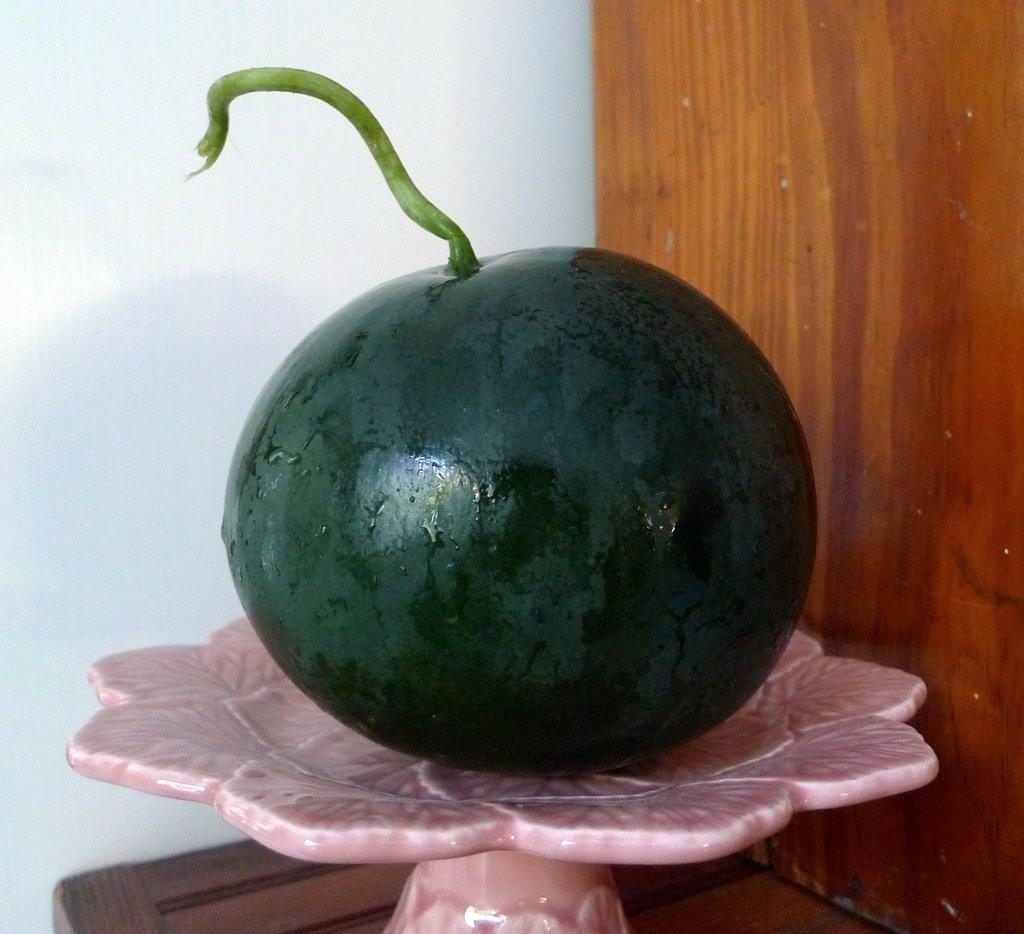What is the main object in the foreground of the picture? There is a desk in the foreground of the picture. What is placed on the desk? There is a watermelon on the desk. Can you describe the desk on the right side of the image? There is a wooden desk on the right side of the image. What color is the wall on the left side of the image? The wall on the left side of the image is painted white. What type of bat is hanging from the ceiling in the image? There is no bat hanging from the ceiling in the image; it only features a desk, a watermelon, and a white wall. Can you see a pipe running along the wall in the image? There is no pipe visible in the image; it only shows a desk, a watermelon, and a white wall. 